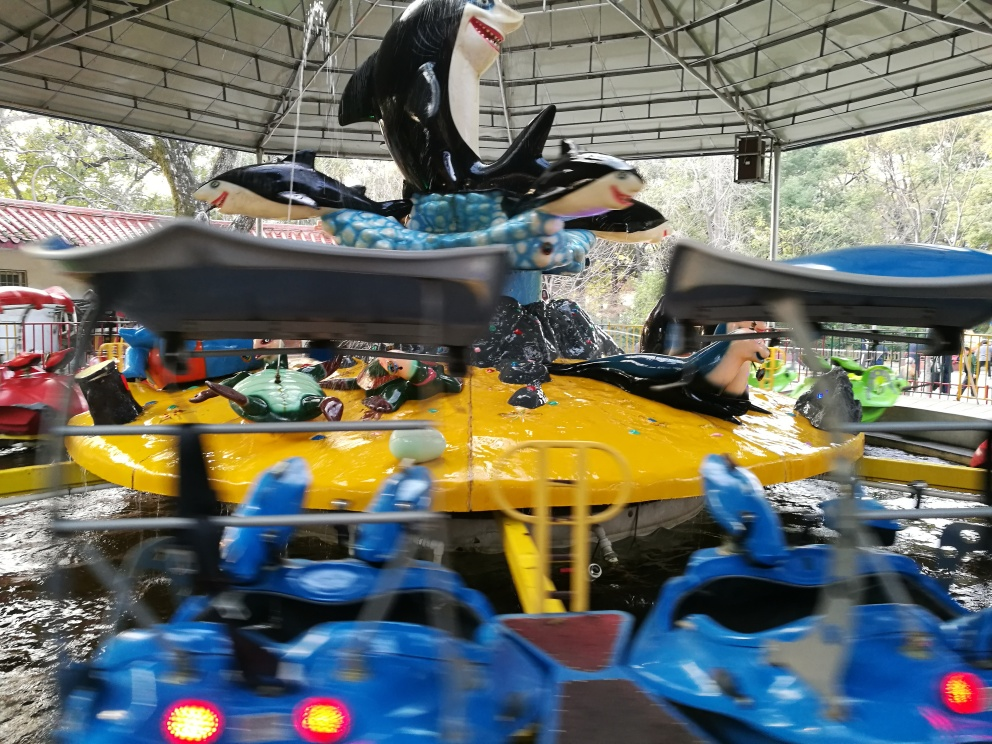Could you describe the atmosphere or mood of the setting? Certainly! Despite the motion blur that suggests action, the setting appears festive and entertaining, clearly part of an amusement park. The splashes of water and bright colors convey a sense of fun and excitement typical of such places. 